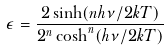Convert formula to latex. <formula><loc_0><loc_0><loc_500><loc_500>\epsilon = \frac { 2 \sinh ( n h \nu / 2 k T ) } { 2 ^ { n } \cosh ^ { n } ( h \nu / 2 k T ) }</formula> 